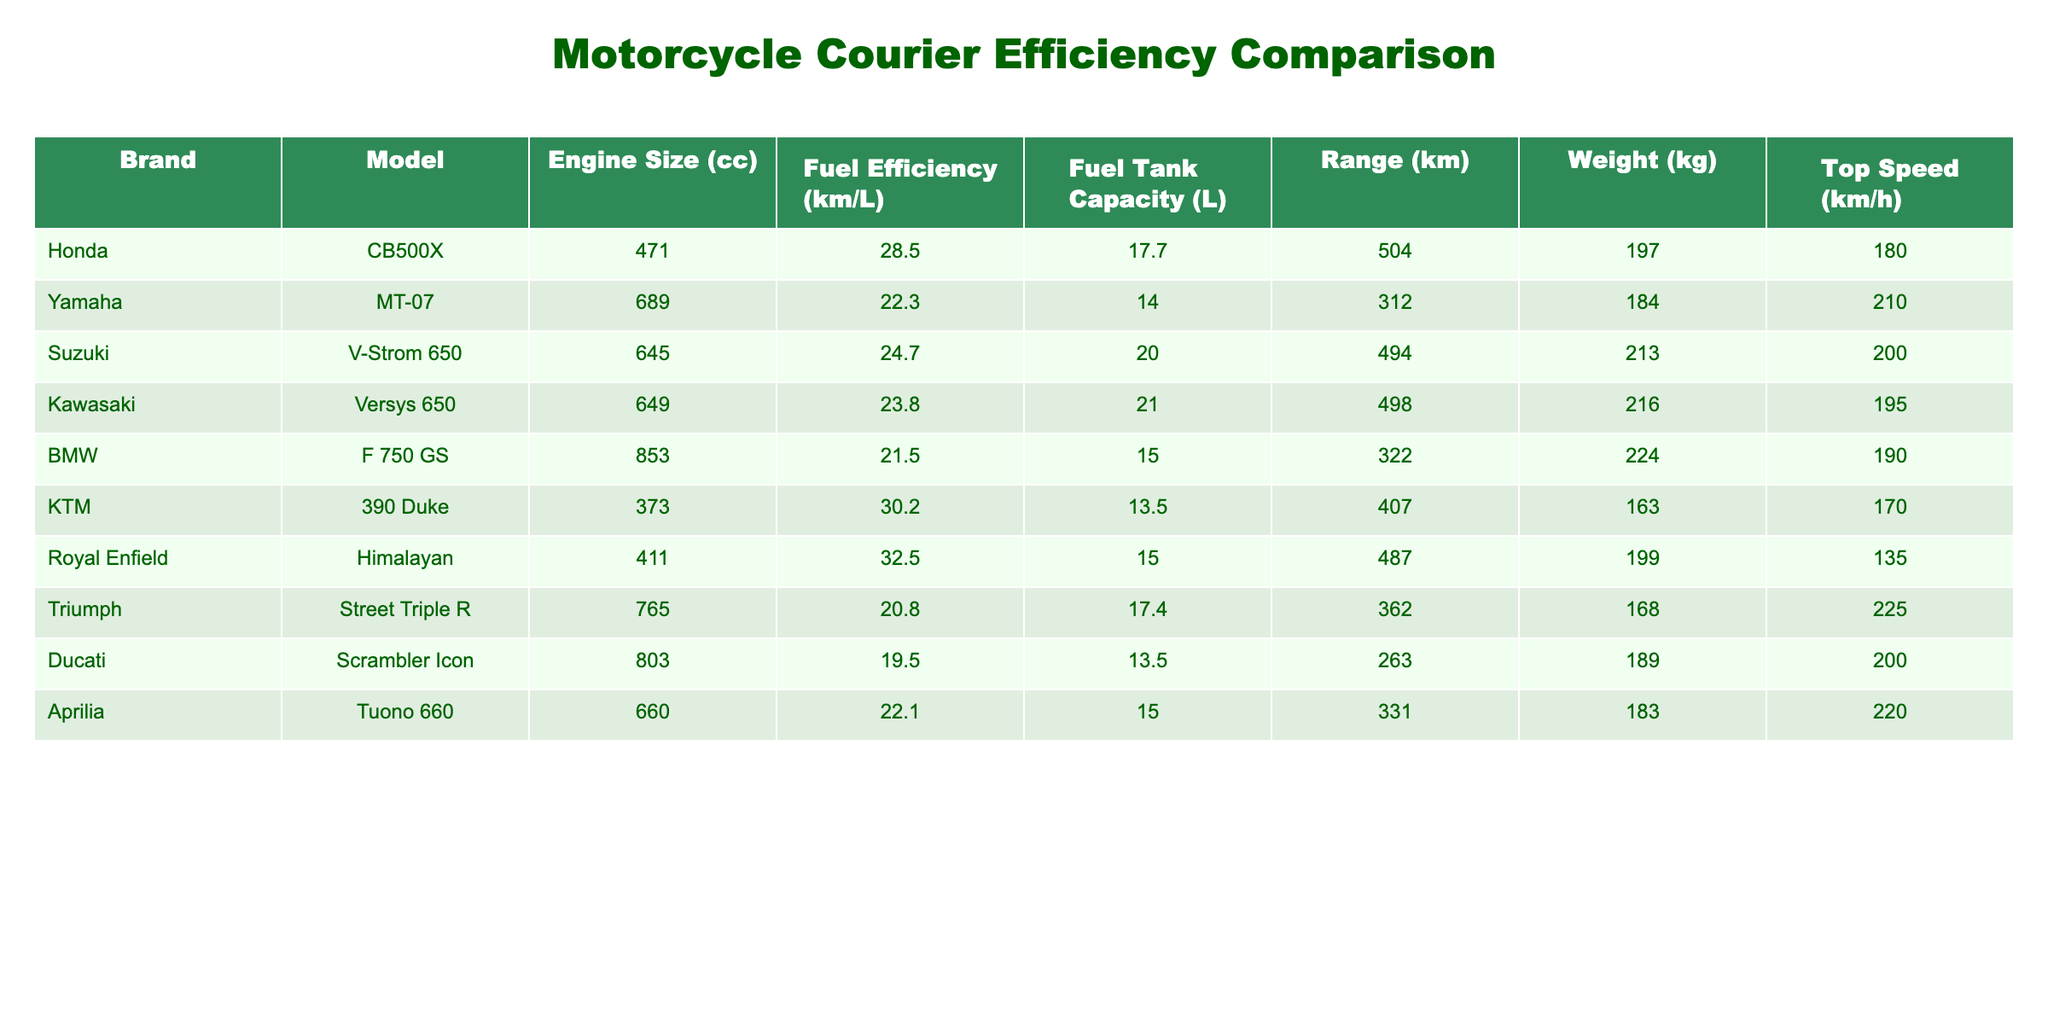What is the fuel efficiency of the Honda CB500X? The fuel efficiency of the Honda CB500X can be found in the table under the "Fuel Efficiency (km/L)" column. It shows a value of 28.5 km/L.
Answer: 28.5 km/L Which motorcycle has the highest fuel efficiency? To find the highest fuel efficiency, we can compare the values in the "Fuel Efficiency (km/L)" column. The Royal Enfield Himalayan has the highest value, which is 32.5 km/L.
Answer: Royal Enfield Himalayan What is the total weight of the KTM 390 Duke and the Ducati Scrambler Icon combined? We look up the weights of both motorcycles in the "Weight (kg)" column. The KTM 390 Duke weighs 163 kg and the Ducati Scrambler Icon weighs 189 kg. Adding these together: 163 + 189 = 352 kg.
Answer: 352 kg Does the Yamaha MT-07 have a range greater than 350 km? We check the "Range (km)" column for the Yamaha MT-07. The value is 312 km, which is less than 350 km. Therefore, the statement is false.
Answer: No If we average the fuel efficiencies of all the motorcycles listed, what value do we get? To find the average, we sum the fuel efficiency values: 28.5 + 22.3 + 24.7 + 23.8 + 21.5 + 30.2 + 32.5 + 20.8 + 19.5 + 22.1 =  255.6 km/L. There are 10 motorcycles, so we divide this sum by 10: 255.6 / 10 = 25.56 km/L.
Answer: 25.56 km/L Which motorcycle has the smallest fuel tank capacity? By examining the "Fuel Tank Capacity (L)" column, we see that the KTM 390 Duke has the smallest tank capacity at 13.5 L.
Answer: KTM 390 Duke What is the difference in weight between the heaviest and the lightest motorcycle? We look for the maximum weight in the "Weight (kg)" column, which is 224 kg for the BMW F 750 GS, and the minimum weight, which is 163 kg for the KTM 390 Duke. The difference is 224 - 163 = 61 kg.
Answer: 61 kg Is the Kawasaki Versys 650 faster than the Triumph Street Triple R? Checking the "Top Speed (km/h)" column, the Kawasaki Versys 650 has a top speed of 195 km/h, while the Triumph Street Triple R has a top speed of 225 km/h. Since 195 is less than 225, the statement is false.
Answer: No 